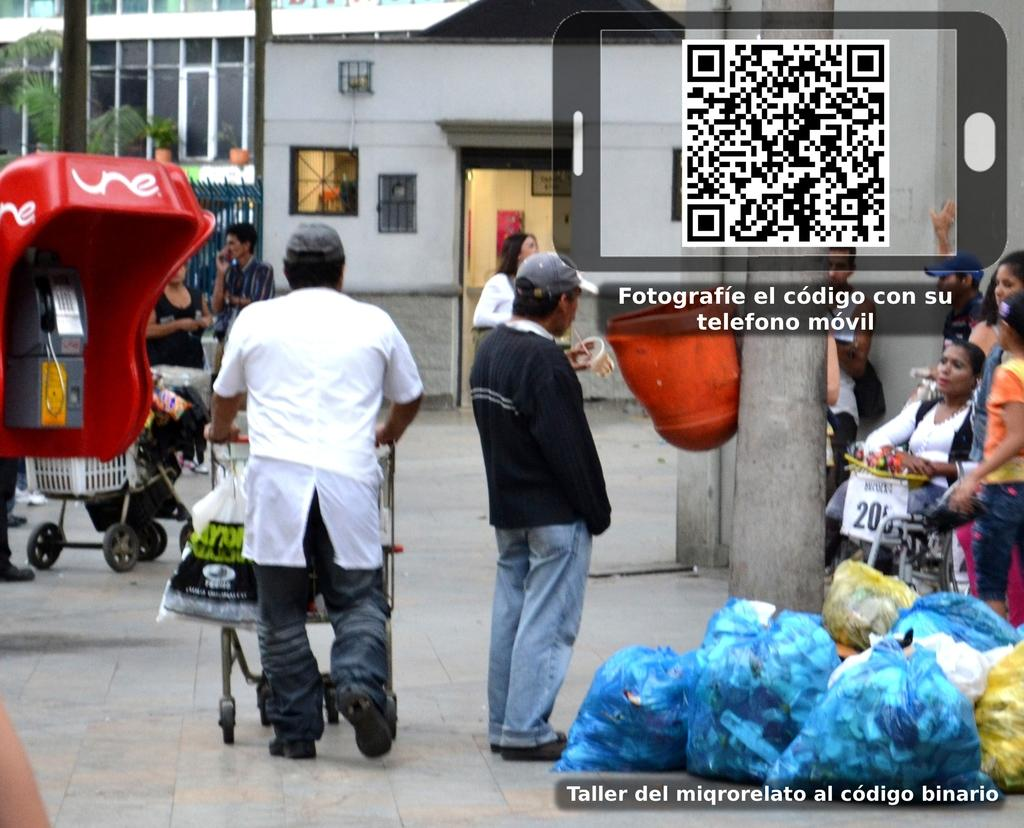How many people are in the image? There are people standing in the image. What is one person holding in the image? One person is holding a trolley. What can be seen in the image besides people? There are bags, buildings, windows, flower pots, and a telephone booth visible in the image. Are there any objects on the floor in the image? Yes, there are objects on the floor in the image. Can you tell me how many quarters are visible in the image? There are no quarters visible in the image. What type of servant is present in the image? There is no servant present in the image. 